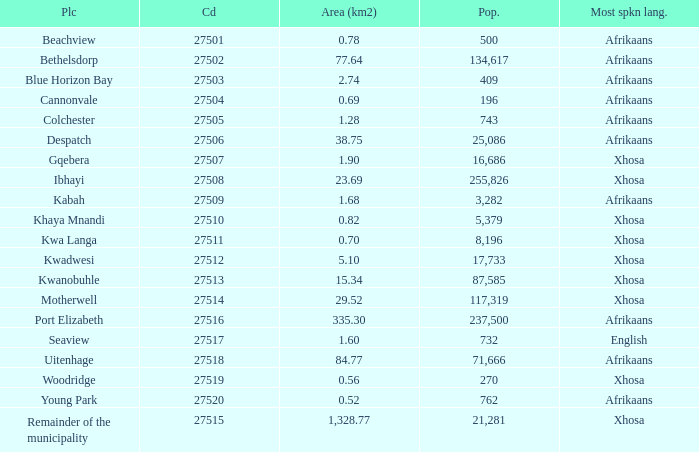What is the lowest area for cannonvale that speaks afrikaans? 0.69. Parse the table in full. {'header': ['Plc', 'Cd', 'Area (km2)', 'Pop.', 'Most spkn lang.'], 'rows': [['Beachview', '27501', '0.78', '500', 'Afrikaans'], ['Bethelsdorp', '27502', '77.64', '134,617', 'Afrikaans'], ['Blue Horizon Bay', '27503', '2.74', '409', 'Afrikaans'], ['Cannonvale', '27504', '0.69', '196', 'Afrikaans'], ['Colchester', '27505', '1.28', '743', 'Afrikaans'], ['Despatch', '27506', '38.75', '25,086', 'Afrikaans'], ['Gqebera', '27507', '1.90', '16,686', 'Xhosa'], ['Ibhayi', '27508', '23.69', '255,826', 'Xhosa'], ['Kabah', '27509', '1.68', '3,282', 'Afrikaans'], ['Khaya Mnandi', '27510', '0.82', '5,379', 'Xhosa'], ['Kwa Langa', '27511', '0.70', '8,196', 'Xhosa'], ['Kwadwesi', '27512', '5.10', '17,733', 'Xhosa'], ['Kwanobuhle', '27513', '15.34', '87,585', 'Xhosa'], ['Motherwell', '27514', '29.52', '117,319', 'Xhosa'], ['Port Elizabeth', '27516', '335.30', '237,500', 'Afrikaans'], ['Seaview', '27517', '1.60', '732', 'English'], ['Uitenhage', '27518', '84.77', '71,666', 'Afrikaans'], ['Woodridge', '27519', '0.56', '270', 'Xhosa'], ['Young Park', '27520', '0.52', '762', 'Afrikaans'], ['Remainder of the municipality', '27515', '1,328.77', '21,281', 'Xhosa']]} 